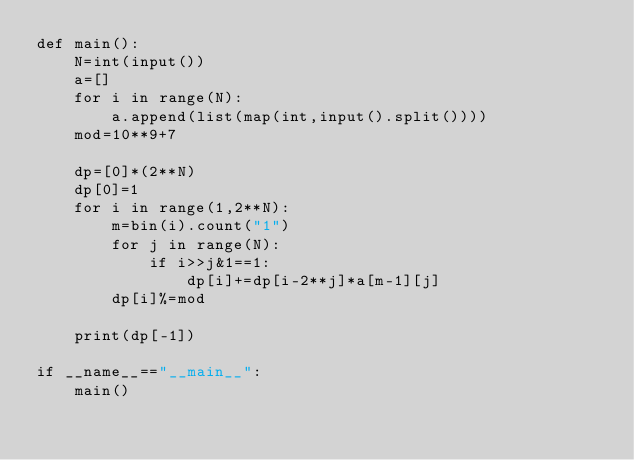Convert code to text. <code><loc_0><loc_0><loc_500><loc_500><_Python_>def main():
    N=int(input())
    a=[]
    for i in range(N):
        a.append(list(map(int,input().split())))
    mod=10**9+7
    
    dp=[0]*(2**N)
    dp[0]=1
    for i in range(1,2**N):
        m=bin(i).count("1")
        for j in range(N):
            if i>>j&1==1:
                dp[i]+=dp[i-2**j]*a[m-1][j]
        dp[i]%=mod
    
    print(dp[-1])

if __name__=="__main__":
    main()</code> 